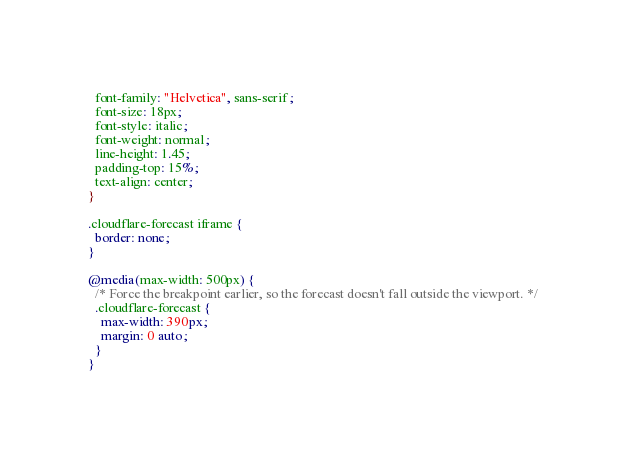<code> <loc_0><loc_0><loc_500><loc_500><_CSS_>  font-family: "Helvetica", sans-serif;
  font-size: 18px;
  font-style: italic;
  font-weight: normal;
  line-height: 1.45;
  padding-top: 15%;
  text-align: center;
}

.cloudflare-forecast iframe {
  border: none;
}

@media(max-width: 500px) {
  /* Force the breakpoint earlier, so the forecast doesn't fall outside the viewport. */
  .cloudflare-forecast {
    max-width: 390px;
    margin: 0 auto;
  }
}
</code> 